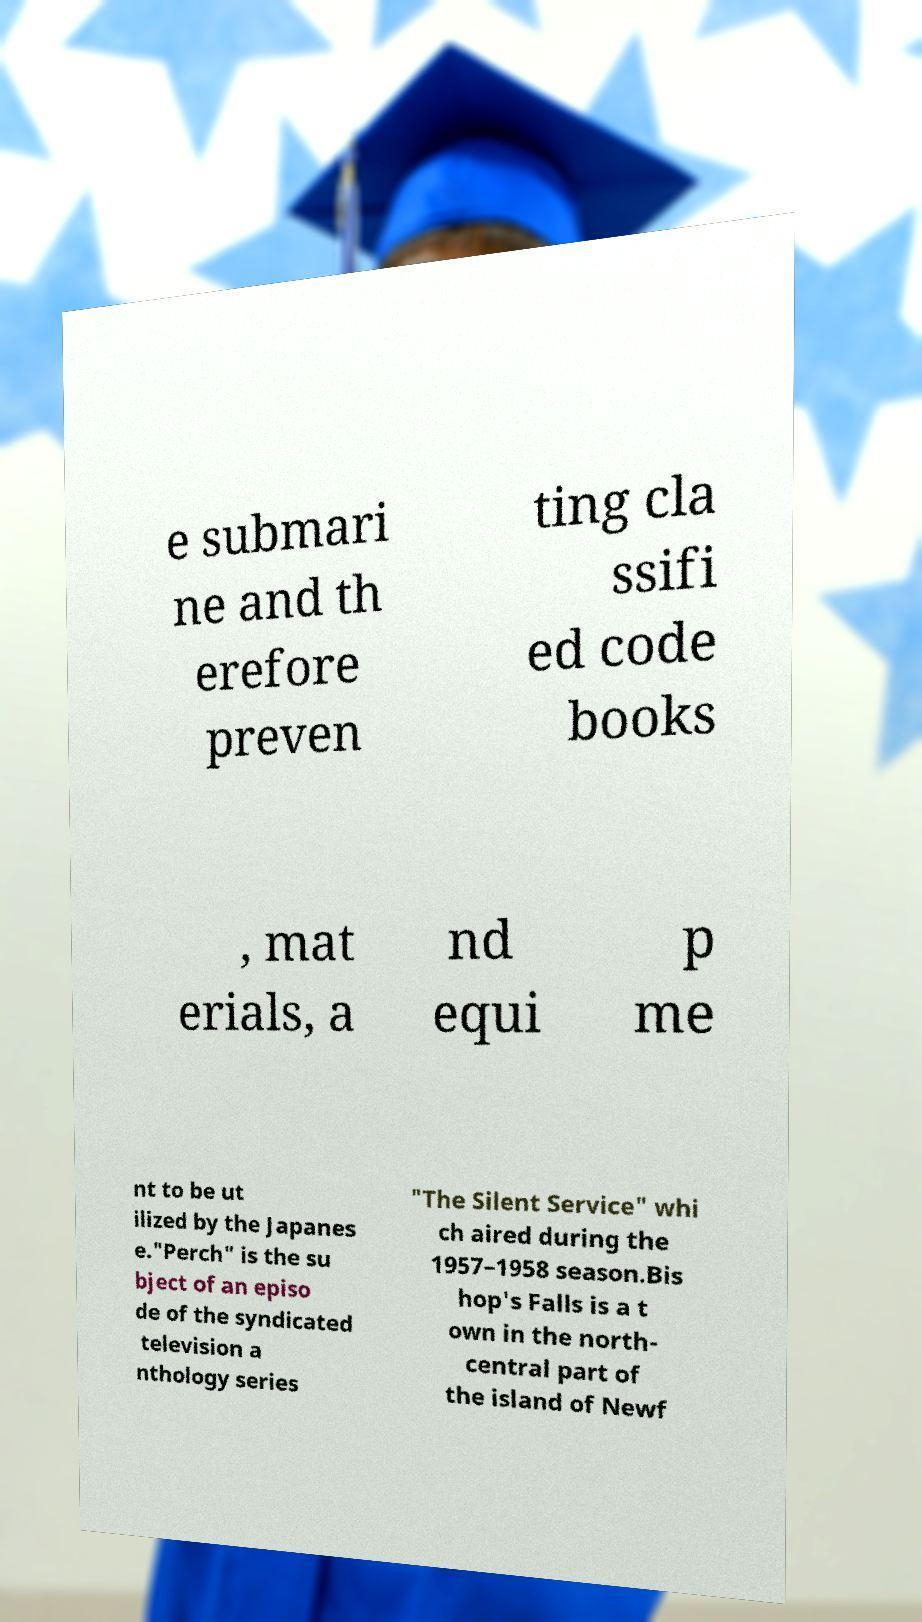Can you read and provide the text displayed in the image?This photo seems to have some interesting text. Can you extract and type it out for me? e submari ne and th erefore preven ting cla ssifi ed code books , mat erials, a nd equi p me nt to be ut ilized by the Japanes e."Perch" is the su bject of an episo de of the syndicated television a nthology series "The Silent Service" whi ch aired during the 1957–1958 season.Bis hop's Falls is a t own in the north- central part of the island of Newf 